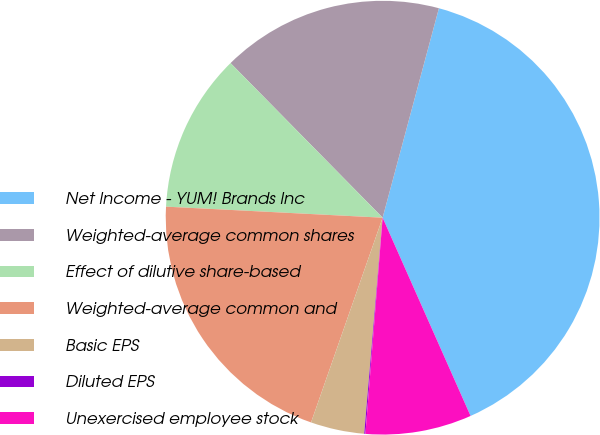Convert chart. <chart><loc_0><loc_0><loc_500><loc_500><pie_chart><fcel>Net Income - YUM! Brands Inc<fcel>Weighted-average common shares<fcel>Effect of dilutive share-based<fcel>Weighted-average common and<fcel>Basic EPS<fcel>Diluted EPS<fcel>Unexercised employee stock<nl><fcel>39.18%<fcel>16.55%<fcel>11.82%<fcel>20.46%<fcel>4.0%<fcel>0.09%<fcel>7.91%<nl></chart> 